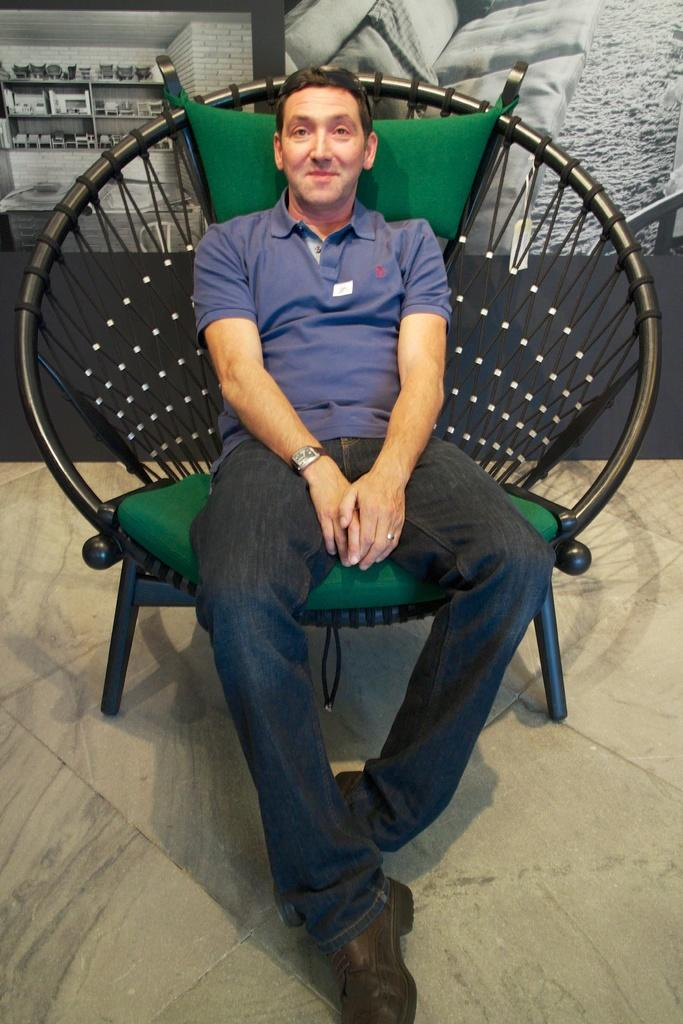Who is present in the image? There is a person in the image. What is the person doing in the image? The person is sitting in a black color chair and smiling. What is the person wearing in the image? The person is wearing a T-shirt. What can be seen in the background of the image? There is a wall in the background of the image. How does the person kick the steam away from the drain in the image? There is no steam or drain present in the image; the person is sitting in a chair and smiling. 